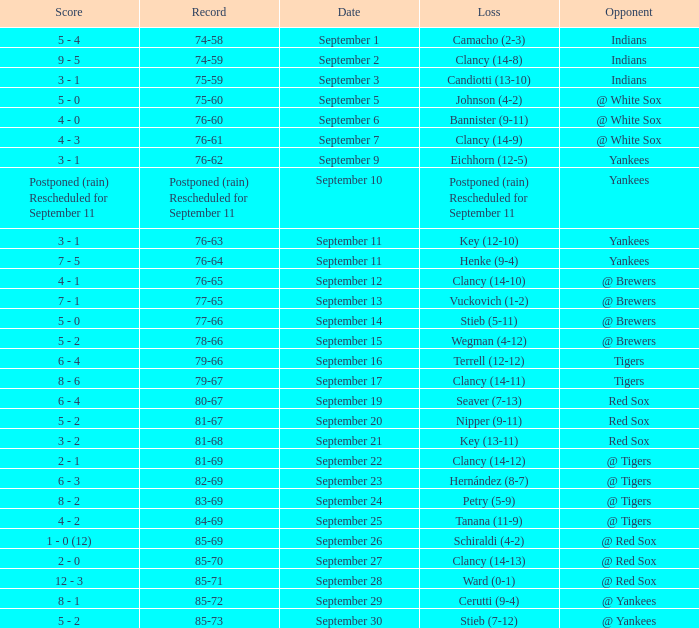Who was the Blue Jays opponent when their record was 84-69? @ Tigers. Can you parse all the data within this table? {'header': ['Score', 'Record', 'Date', 'Loss', 'Opponent'], 'rows': [['5 - 4', '74-58', 'September 1', 'Camacho (2-3)', 'Indians'], ['9 - 5', '74-59', 'September 2', 'Clancy (14-8)', 'Indians'], ['3 - 1', '75-59', 'September 3', 'Candiotti (13-10)', 'Indians'], ['5 - 0', '75-60', 'September 5', 'Johnson (4-2)', '@ White Sox'], ['4 - 0', '76-60', 'September 6', 'Bannister (9-11)', '@ White Sox'], ['4 - 3', '76-61', 'September 7', 'Clancy (14-9)', '@ White Sox'], ['3 - 1', '76-62', 'September 9', 'Eichhorn (12-5)', 'Yankees'], ['Postponed (rain) Rescheduled for September 11', 'Postponed (rain) Rescheduled for September 11', 'September 10', 'Postponed (rain) Rescheduled for September 11', 'Yankees'], ['3 - 1', '76-63', 'September 11', 'Key (12-10)', 'Yankees'], ['7 - 5', '76-64', 'September 11', 'Henke (9-4)', 'Yankees'], ['4 - 1', '76-65', 'September 12', 'Clancy (14-10)', '@ Brewers'], ['7 - 1', '77-65', 'September 13', 'Vuckovich (1-2)', '@ Brewers'], ['5 - 0', '77-66', 'September 14', 'Stieb (5-11)', '@ Brewers'], ['5 - 2', '78-66', 'September 15', 'Wegman (4-12)', '@ Brewers'], ['6 - 4', '79-66', 'September 16', 'Terrell (12-12)', 'Tigers'], ['8 - 6', '79-67', 'September 17', 'Clancy (14-11)', 'Tigers'], ['6 - 4', '80-67', 'September 19', 'Seaver (7-13)', 'Red Sox'], ['5 - 2', '81-67', 'September 20', 'Nipper (9-11)', 'Red Sox'], ['3 - 2', '81-68', 'September 21', 'Key (13-11)', 'Red Sox'], ['2 - 1', '81-69', 'September 22', 'Clancy (14-12)', '@ Tigers'], ['6 - 3', '82-69', 'September 23', 'Hernández (8-7)', '@ Tigers'], ['8 - 2', '83-69', 'September 24', 'Petry (5-9)', '@ Tigers'], ['4 - 2', '84-69', 'September 25', 'Tanana (11-9)', '@ Tigers'], ['1 - 0 (12)', '85-69', 'September 26', 'Schiraldi (4-2)', '@ Red Sox'], ['2 - 0', '85-70', 'September 27', 'Clancy (14-13)', '@ Red Sox'], ['12 - 3', '85-71', 'September 28', 'Ward (0-1)', '@ Red Sox'], ['8 - 1', '85-72', 'September 29', 'Cerutti (9-4)', '@ Yankees'], ['5 - 2', '85-73', 'September 30', 'Stieb (7-12)', '@ Yankees']]} 